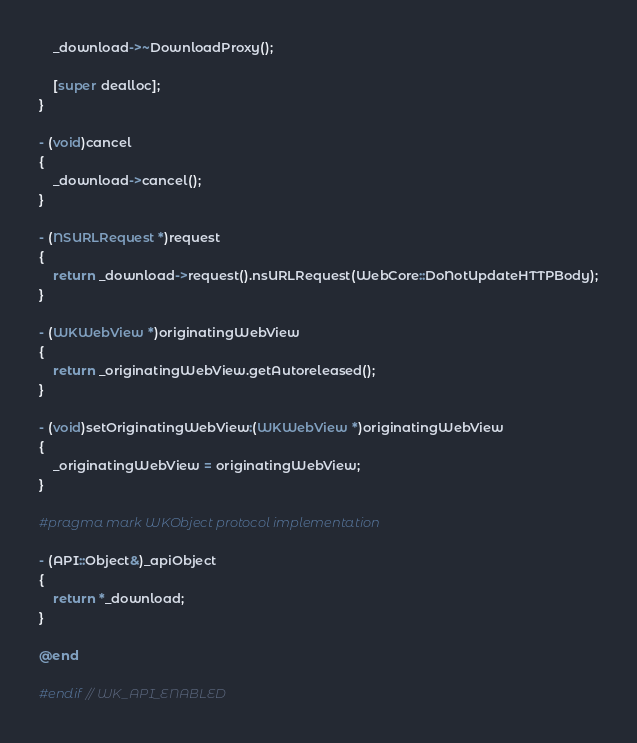Convert code to text. <code><loc_0><loc_0><loc_500><loc_500><_ObjectiveC_>    _download->~DownloadProxy();

    [super dealloc];
}

- (void)cancel
{
    _download->cancel();
}

- (NSURLRequest *)request
{
    return _download->request().nsURLRequest(WebCore::DoNotUpdateHTTPBody);
}

- (WKWebView *)originatingWebView
{
    return _originatingWebView.getAutoreleased();
}

- (void)setOriginatingWebView:(WKWebView *)originatingWebView
{
    _originatingWebView = originatingWebView;
}

#pragma mark WKObject protocol implementation

- (API::Object&)_apiObject
{
    return *_download;
}

@end

#endif // WK_API_ENABLED
</code> 